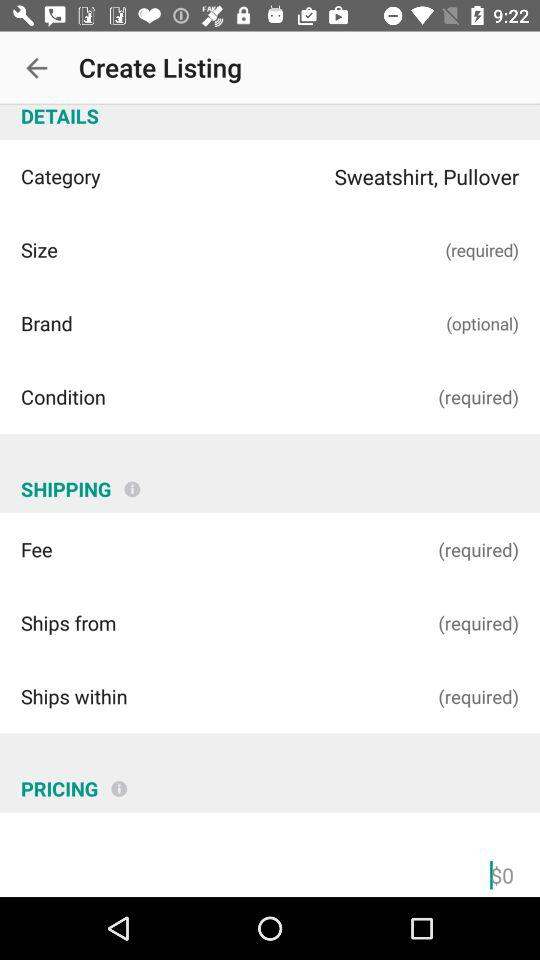How much is the shipping fee?
When the provided information is insufficient, respond with <no answer>. <no answer> 